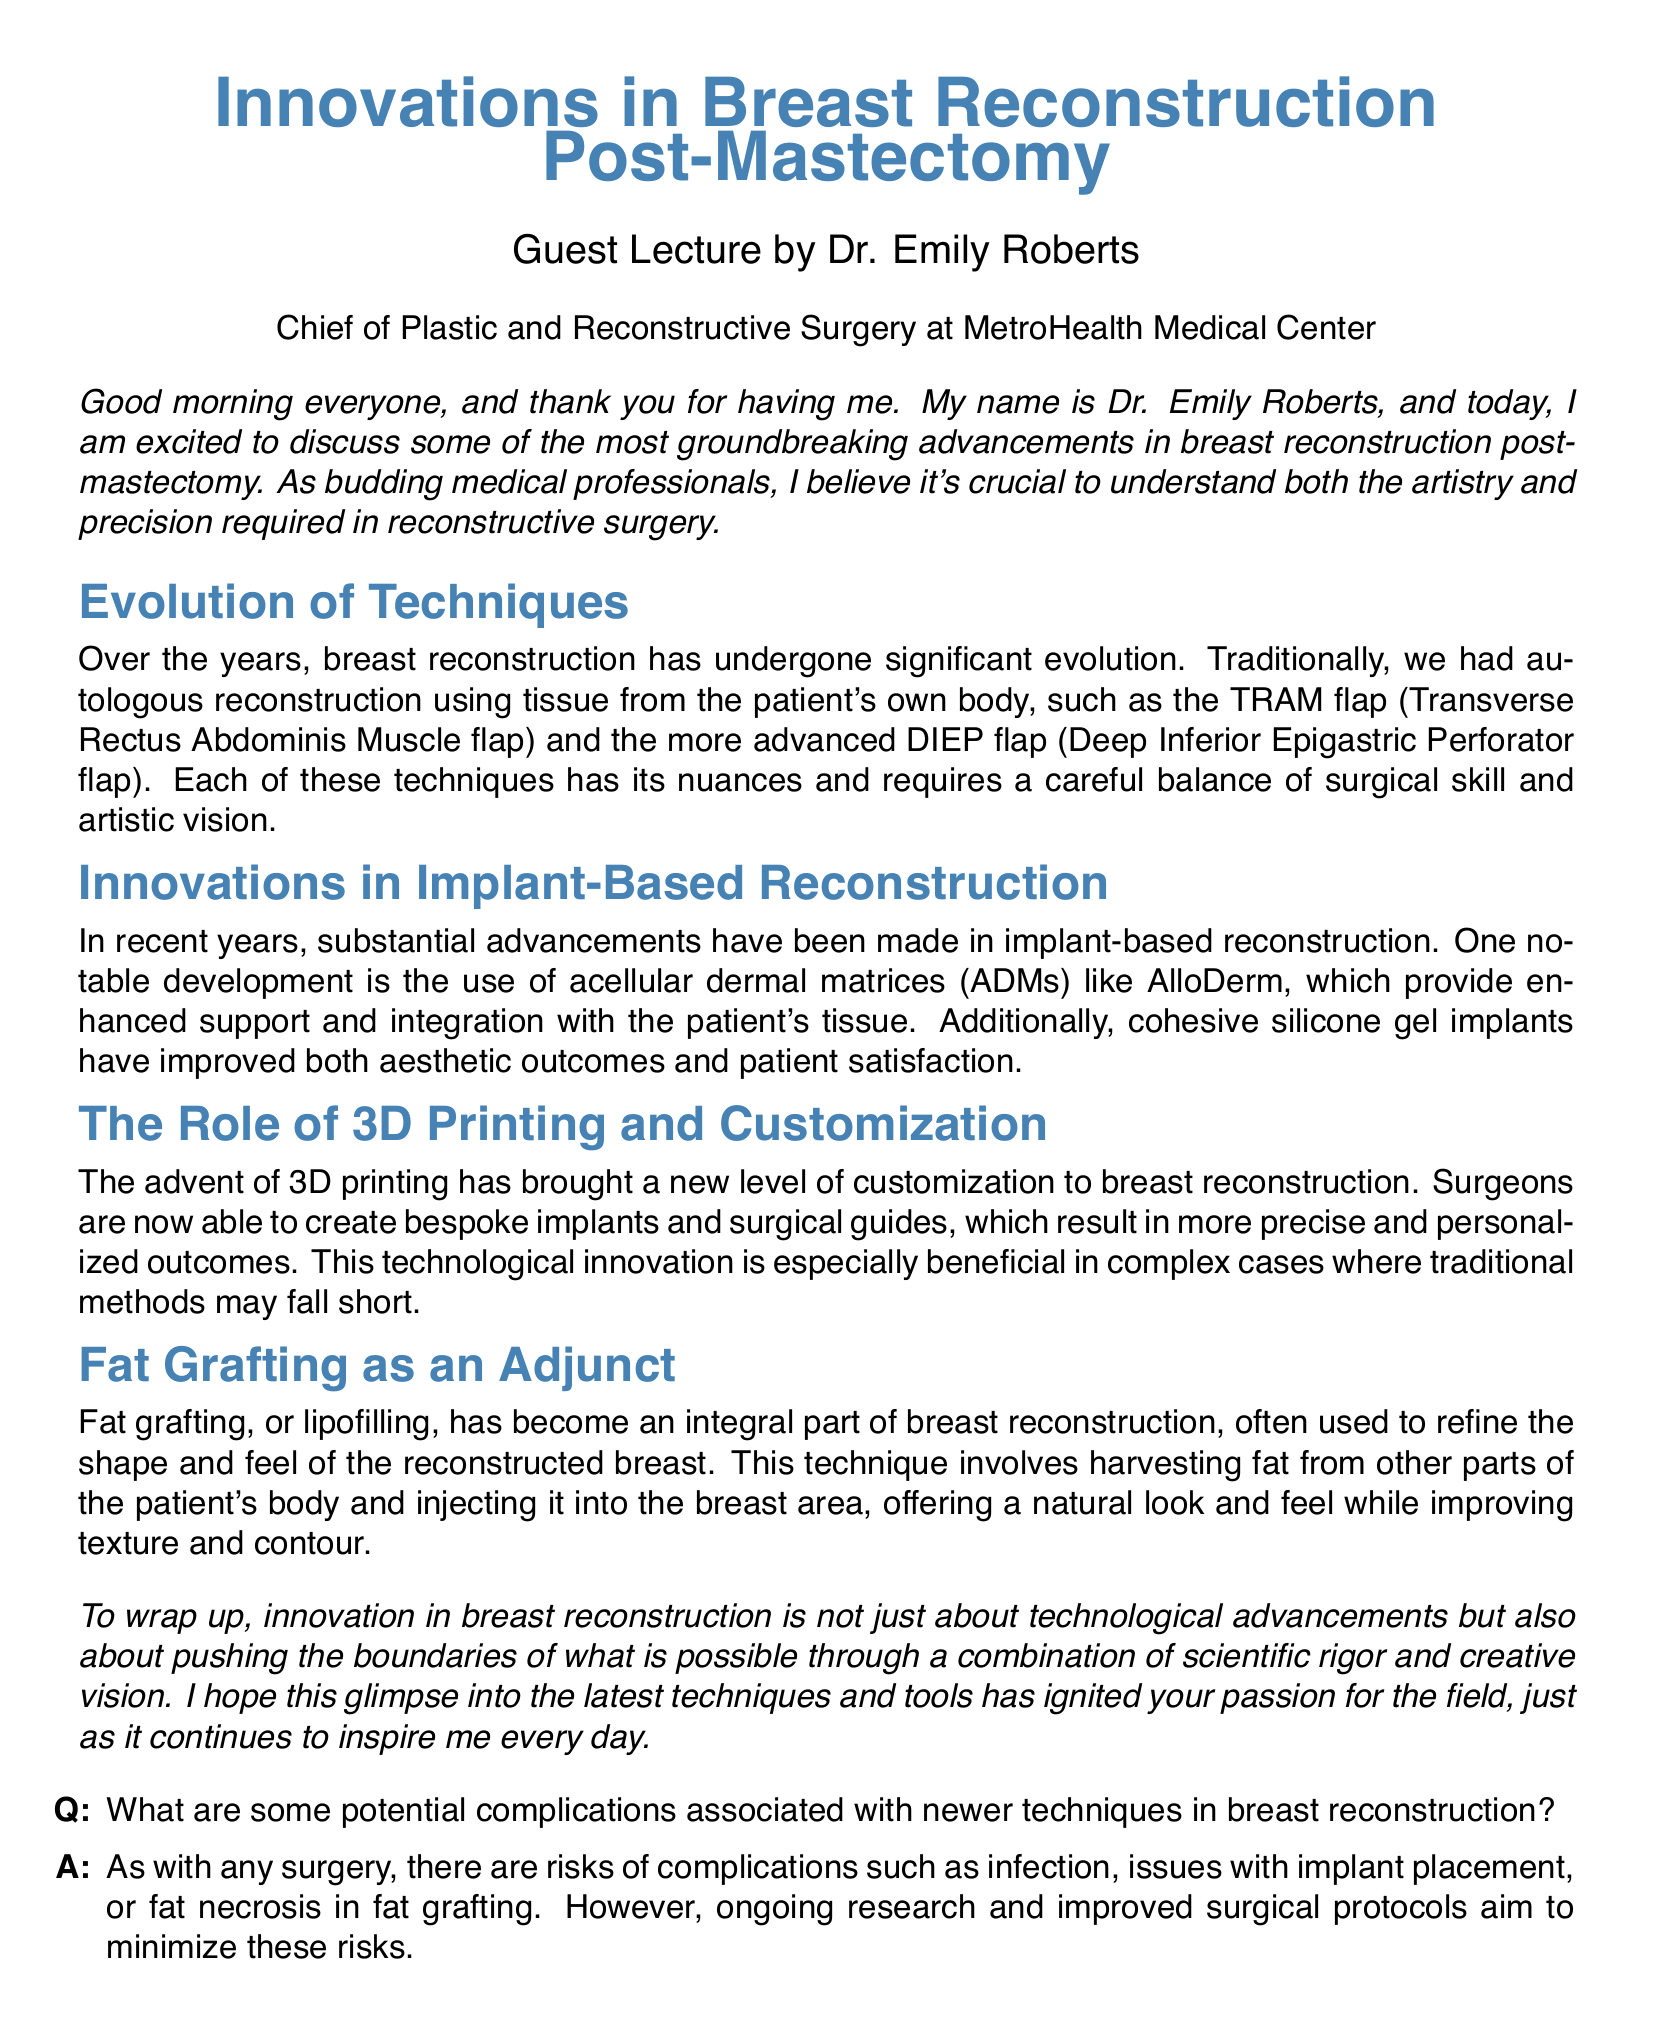What is the name of the guest speaker? The document states that the guest speaker is Dr. Emily Roberts.
Answer: Dr. Emily Roberts What is the title of the lecture? The title of the lecture, as indicated in the document, is "Innovations in Breast Reconstruction Post-Mastectomy."
Answer: Innovations in Breast Reconstruction Post-Mastectomy What does ADM stand for? The document refers to acellular dermal matrices, abbreviated as ADM.
Answer: ADM What technique does the acronym TRAM represent? The document mentions that TRAM stands for Transverse Rectus Abdominis Muscle flap.
Answer: Transverse Rectus Abdominis Muscle flap What is one advantage of cohesive silicone gel implants? The document notes that cohesive silicone gel implants have improved aesthetic outcomes and patient satisfaction.
Answer: Improved aesthetic outcomes What technique involves harvesting fat from other parts of the body? The document describes fat grafting, or lipofilling, as the technique for harvesting fat.
Answer: Fat grafting What does Dr. Emily Roberts emphasize as essential in reconstructive surgery? The document highlights the importance of both artistry and precision in reconstructive surgery.
Answer: Artistry and precision What technological advancement enhances customization in breast reconstruction? The document states that 3D printing brings a new level of customization to breast reconstruction.
Answer: 3D printing What are the risks associated with newer techniques in breast reconstruction? The document mentions risks including infection, issues with implant placement, or fat necrosis.
Answer: Infection, implant issues, fat necrosis 